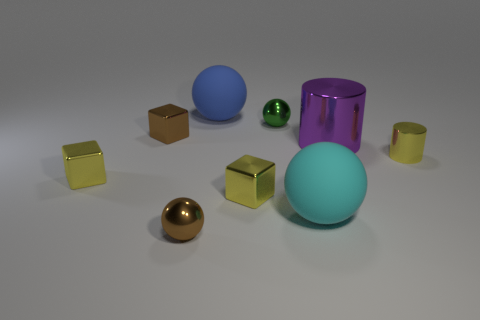Is there a big blue matte thing that has the same shape as the cyan thing?
Give a very brief answer. Yes. Do the green thing and the block that is to the right of the brown metal ball have the same size?
Provide a succinct answer. Yes. What number of things are either metal cylinders in front of the large purple metallic cylinder or metallic blocks in front of the brown cube?
Provide a short and direct response. 3. Are there more small yellow things that are in front of the brown sphere than big gray shiny things?
Your response must be concise. No. How many green shiny things are the same size as the brown sphere?
Keep it short and to the point. 1. Is the size of the cube right of the large blue matte ball the same as the shiny ball behind the purple metallic object?
Provide a succinct answer. Yes. How big is the cylinder that is in front of the large metallic cylinder?
Offer a very short reply. Small. What is the size of the yellow cube to the left of the brown shiny thing that is behind the small cylinder?
Offer a terse response. Small. What is the material of the brown block that is the same size as the green shiny ball?
Provide a short and direct response. Metal. There is a blue rubber thing; are there any big things in front of it?
Your answer should be compact. Yes. 